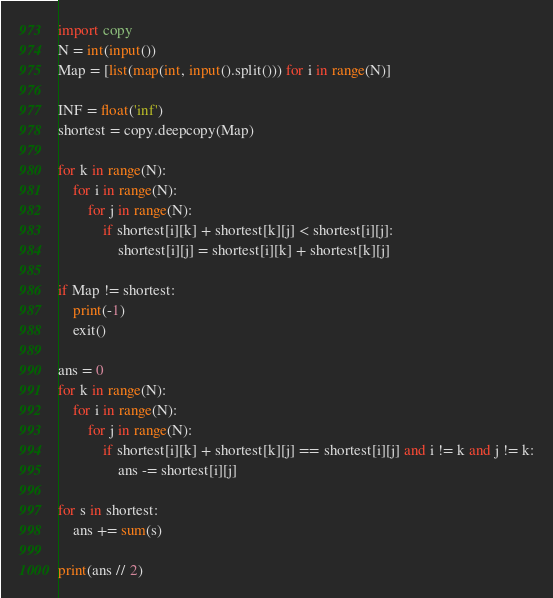Convert code to text. <code><loc_0><loc_0><loc_500><loc_500><_Python_>import copy
N = int(input())
Map = [list(map(int, input().split())) for i in range(N)]

INF = float('inf')
shortest = copy.deepcopy(Map)

for k in range(N):
    for i in range(N):
        for j in range(N):
            if shortest[i][k] + shortest[k][j] < shortest[i][j]:
                shortest[i][j] = shortest[i][k] + shortest[k][j]

if Map != shortest:
    print(-1)
    exit()

ans = 0
for k in range(N):
    for i in range(N):
        for j in range(N):
            if shortest[i][k] + shortest[k][j] == shortest[i][j] and i != k and j != k:
                ans -= shortest[i][j]

for s in shortest:
    ans += sum(s)

print(ans // 2)</code> 